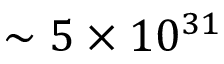<formula> <loc_0><loc_0><loc_500><loc_500>\sim 5 \times 1 0 ^ { 3 1 }</formula> 